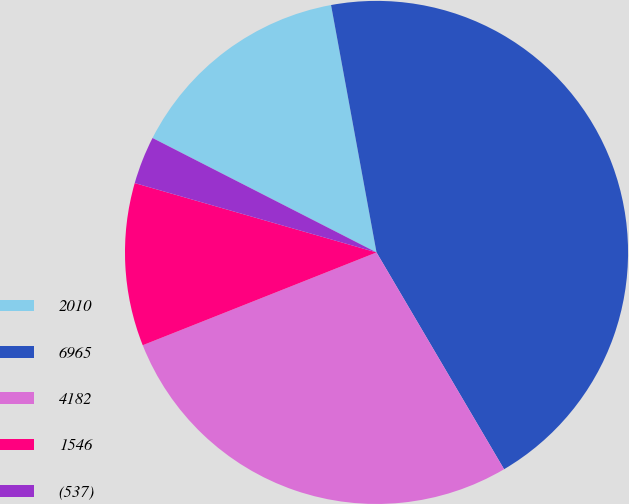Convert chart to OTSL. <chart><loc_0><loc_0><loc_500><loc_500><pie_chart><fcel>2010<fcel>6965<fcel>4182<fcel>1546<fcel>(537)<nl><fcel>14.59%<fcel>44.43%<fcel>27.45%<fcel>10.46%<fcel>3.07%<nl></chart> 